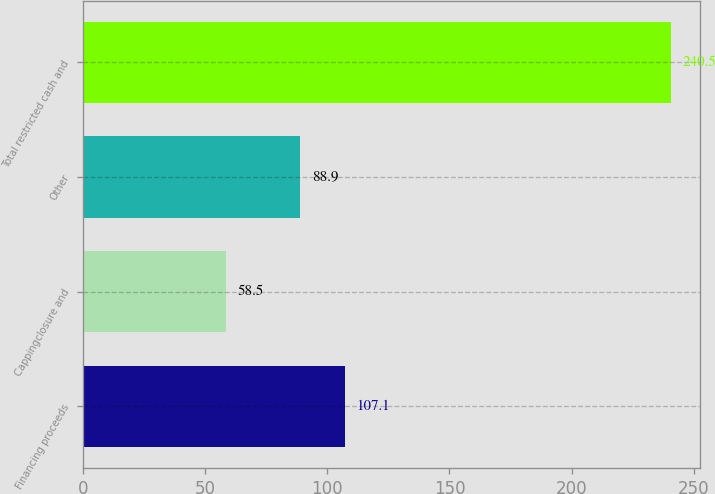Convert chart. <chart><loc_0><loc_0><loc_500><loc_500><bar_chart><fcel>Financing proceeds<fcel>Cappingclosure and<fcel>Other<fcel>Total restricted cash and<nl><fcel>107.1<fcel>58.5<fcel>88.9<fcel>240.5<nl></chart> 